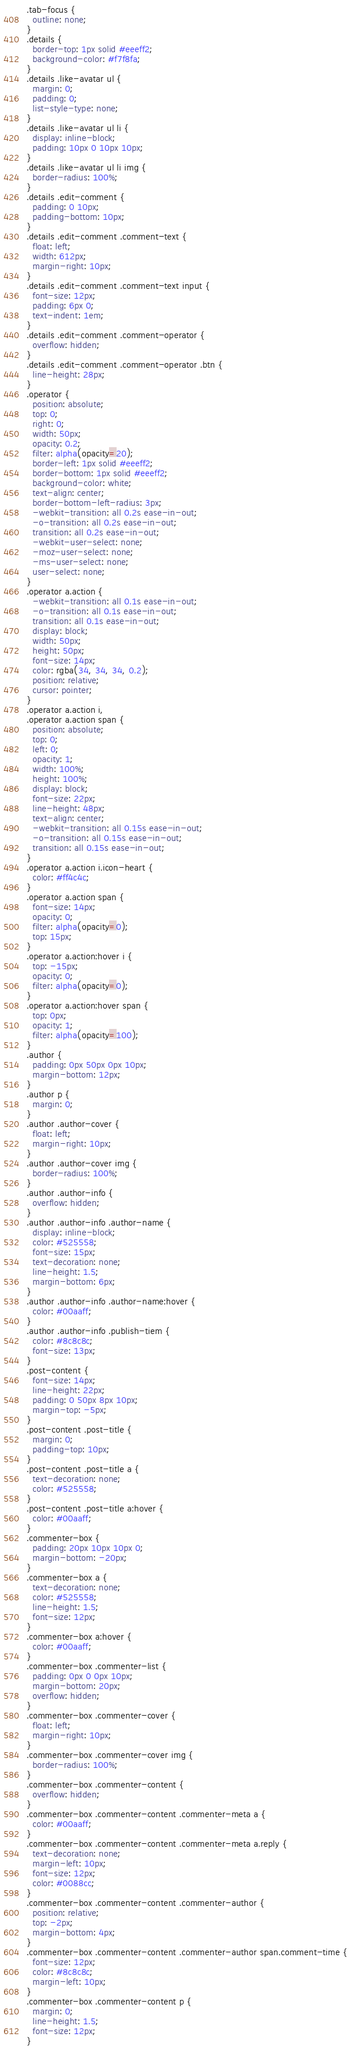Convert code to text. <code><loc_0><loc_0><loc_500><loc_500><_CSS_>.tab-focus {
  outline: none;
}
.details {
  border-top: 1px solid #eeeff2;
  background-color: #f7f8fa;
}
.details .like-avatar ul {
  margin: 0;
  padding: 0;
  list-style-type: none;
}
.details .like-avatar ul li {
  display: inline-block;
  padding: 10px 0 10px 10px;
}
.details .like-avatar ul li img {
  border-radius: 100%;
}
.details .edit-comment {
  padding: 0 10px;
  padding-bottom: 10px;
}
.details .edit-comment .comment-text {
  float: left;
  width: 612px;
  margin-right: 10px;
}
.details .edit-comment .comment-text input {
  font-size: 12px;
  padding: 6px 0;
  text-indent: 1em;
}
.details .edit-comment .comment-operator {
  overflow: hidden;
}
.details .edit-comment .comment-operator .btn {
  line-height: 28px;
}
.operator {
  position: absolute;
  top: 0;
  right: 0;
  width: 50px;
  opacity: 0.2;
  filter: alpha(opacity=20);
  border-left: 1px solid #eeeff2;
  border-bottom: 1px solid #eeeff2;
  background-color: white;
  text-align: center;
  border-bottom-left-radius: 3px;
  -webkit-transition: all 0.2s ease-in-out;
  -o-transition: all 0.2s ease-in-out;
  transition: all 0.2s ease-in-out;
  -webkit-user-select: none;
  -moz-user-select: none;
  -ms-user-select: none;
  user-select: none;
}
.operator a.action {
  -webkit-transition: all 0.1s ease-in-out;
  -o-transition: all 0.1s ease-in-out;
  transition: all 0.1s ease-in-out;
  display: block;
  width: 50px;
  height: 50px;
  font-size: 14px;
  color: rgba(34, 34, 34, 0.2);
  position: relative;
  cursor: pointer;
}
.operator a.action i,
.operator a.action span {
  position: absolute;
  top: 0;
  left: 0;
  opacity: 1;
  width: 100%;
  height: 100%;
  display: block;
  font-size: 22px;
  line-height: 48px;
  text-align: center;
  -webkit-transition: all 0.15s ease-in-out;
  -o-transition: all 0.15s ease-in-out;
  transition: all 0.15s ease-in-out;
}
.operator a.action i.icon-heart {
  color: #ff4c4c;
}
.operator a.action span {
  font-size: 14px;
  opacity: 0;
  filter: alpha(opacity=0);
  top: 15px;
}
.operator a.action:hover i {
  top: -15px;
  opacity: 0;
  filter: alpha(opacity=0);
}
.operator a.action:hover span {
  top: 0px;
  opacity: 1;
  filter: alpha(opacity=100);
}
.author {
  padding: 0px 50px 0px 10px;
  margin-bottom: 12px;
}
.author p {
  margin: 0;
}
.author .author-cover {
  float: left;
  margin-right: 10px;
}
.author .author-cover img {
  border-radius: 100%;
}
.author .author-info {
  overflow: hidden;
}
.author .author-info .author-name {
  display: inline-block;
  color: #525558;
  font-size: 15px;
  text-decoration: none;
  line-height: 1.5;
  margin-bottom: 6px;
}
.author .author-info .author-name:hover {
  color: #00aaff;
}
.author .author-info .publish-tiem {
  color: #8c8c8c;
  font-size: 13px;
}
.post-content {
  font-size: 14px;
  line-height: 22px;
  padding: 0 50px 8px 10px;
  margin-top: -5px;
}
.post-content .post-title {
  margin: 0;
  padding-top: 10px;
}
.post-content .post-title a {
  text-decoration: none;
  color: #525558;
}
.post-content .post-title a:hover {
  color: #00aaff;
}
.commenter-box {
  padding: 20px 10px 10px 0;
  margin-bottom: -20px;
}
.commenter-box a {
  text-decoration: none;
  color: #525558;
  line-height: 1.5;
  font-size: 12px;
}
.commenter-box a:hover {
  color: #00aaff;
}
.commenter-box .commenter-list {
  padding: 0px 0 0px 10px;
  margin-bottom: 20px;
  overflow: hidden;
}
.commenter-box .commenter-cover {
  float: left;
  margin-right: 10px;
}
.commenter-box .commenter-cover img {
  border-radius: 100%;
}
.commenter-box .commenter-content {
  overflow: hidden;
}
.commenter-box .commenter-content .commenter-meta a {
  color: #00aaff;
}
.commenter-box .commenter-content .commenter-meta a.reply {
  text-decoration: none;
  margin-left: 10px;
  font-size: 12px;
  color: #0088cc;
}
.commenter-box .commenter-content .commenter-author {
  position: relative;
  top: -2px;
  margin-bottom: 4px;
}
.commenter-box .commenter-content .commenter-author span.comment-time {
  font-size: 12px;
  color: #8c8c8c;
  margin-left: 10px;
}
.commenter-box .commenter-content p {
  margin: 0;
  line-height: 1.5;
  font-size: 12px;
}
</code> 